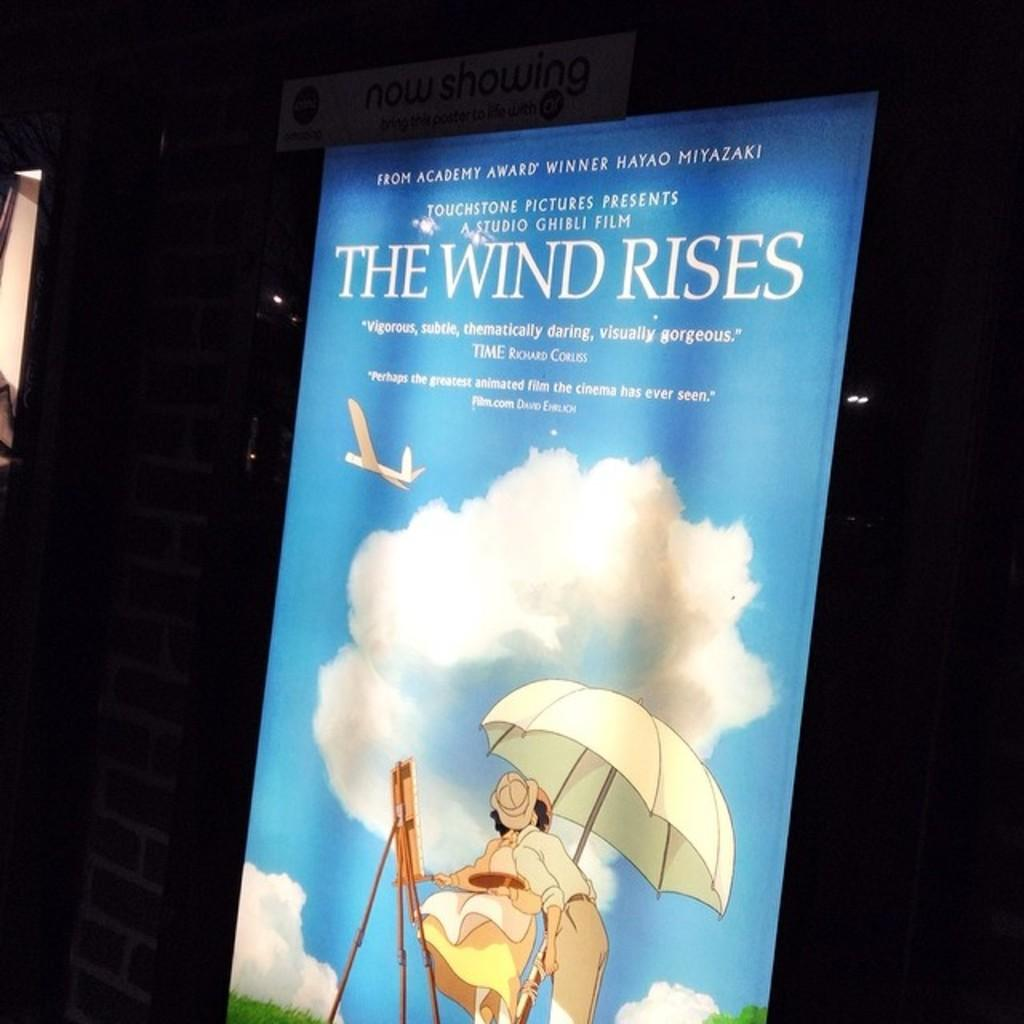What is the main object in the image? There is an advertisement board in the image. What else can be seen in the background of the image? There is a wall in the image. Is there any text or information displayed in the image? Yes, there is a name board in the image. How many trains can be seen passing by in the image? There are no trains visible in the image. What type of sofa is featured in the image? There is no sofa present in the image. 